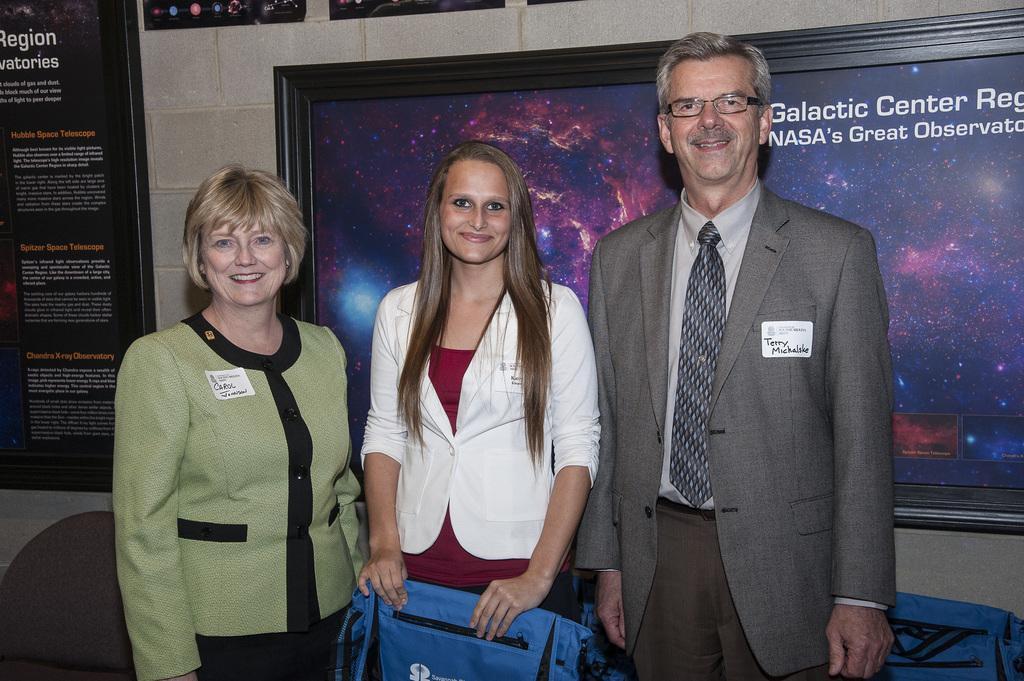In one or two sentences, can you explain what this image depicts? This image is taken indoors. In the background there is a wall with a few posts and text on them and there is a board with a text on the wall. In the middle of the image two women and a man are standing on the floor and they are with smiling faces and there is an empty chair. 